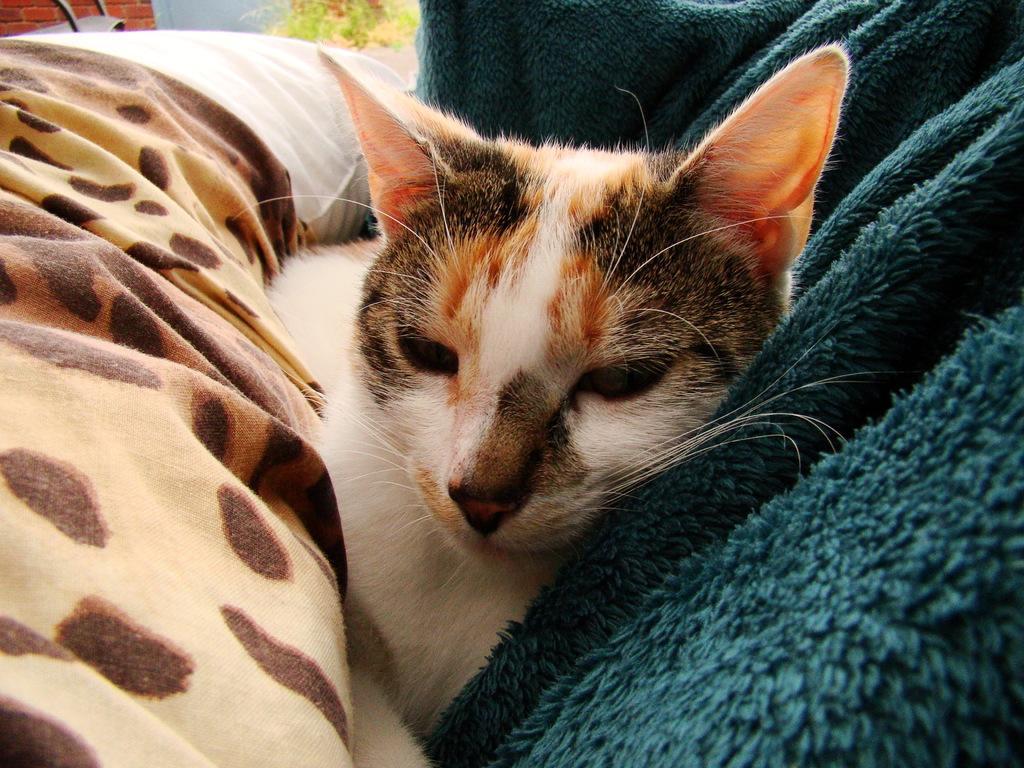Can you describe this image briefly? In this image we can see a cat under a blanket. In the top left, we can see a pillow, plants and a wall. On the right side, we can see another blanket. 